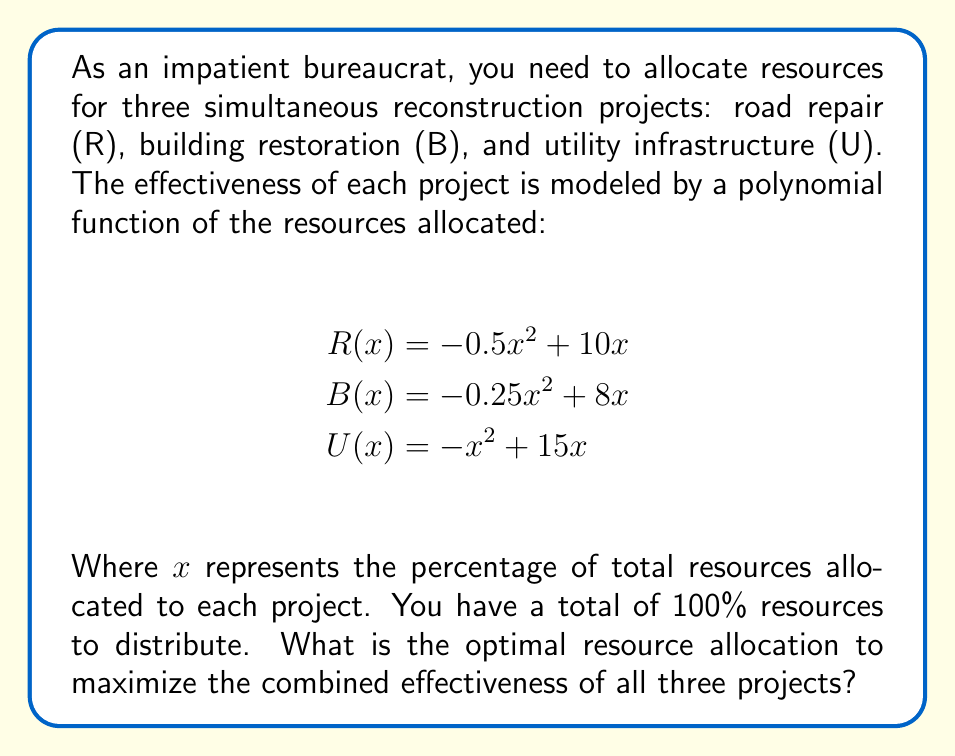Provide a solution to this math problem. To solve this problem, we'll follow these steps:

1) First, we need to create a function that represents the total effectiveness of all three projects combined:

   $$ T(x, y, z) = R(x) + B(y) + U(z) $$
   $$ T(x, y, z) = (-0.5x^2 + 10x) + (-0.25y^2 + 8y) + (-z^2 + 15z) $$

2) We have a constraint that the total resources must equal 100%:

   $$ x + y + z = 100 $$

3) To maximize T, we need to find where its partial derivatives are zero:

   $$ \frac{\partial T}{\partial x} = -x + 10 = 0 $$
   $$ \frac{\partial T}{\partial y} = -0.5y + 8 = 0 $$
   $$ \frac{\partial T}{\partial z} = -2z + 15 = 0 $$

4) Solving these equations:

   $$ x = 10 $$
   $$ y = 16 $$
   $$ z = 7.5 $$

5) However, these don't sum to 100. We need to scale them proportionally:

   $$ \text{Total} = 10 + 16 + 7.5 = 33.5 $$
   $$ \text{Scale factor} = 100 / 33.5 \approx 2.985 $$

6) Multiplying each value by the scale factor:

   $$ x \approx 10 * 2.985 \approx 29.85\% $$
   $$ y \approx 16 * 2.985 \approx 47.76\% $$
   $$ z \approx 7.5 * 2.985 \approx 22.39\% $$

7) Rounding to the nearest whole percentage:

   Road repair (R): 30%
   Building restoration (B): 48%
   Utility infrastructure (U): 22%
Answer: R: 30%, B: 48%, U: 22% 